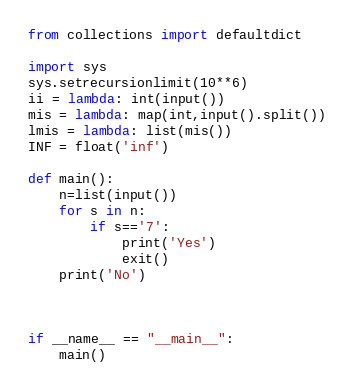<code> <loc_0><loc_0><loc_500><loc_500><_Python_>from collections import defaultdict

import sys
sys.setrecursionlimit(10**6)
ii = lambda: int(input())
mis = lambda: map(int,input().split())
lmis = lambda: list(mis())
INF = float('inf')

def main():
    n=list(input())
    for s in n:
        if s=='7':
            print('Yes')
            exit()
    print('No')



if __name__ == "__main__":
    main()</code> 